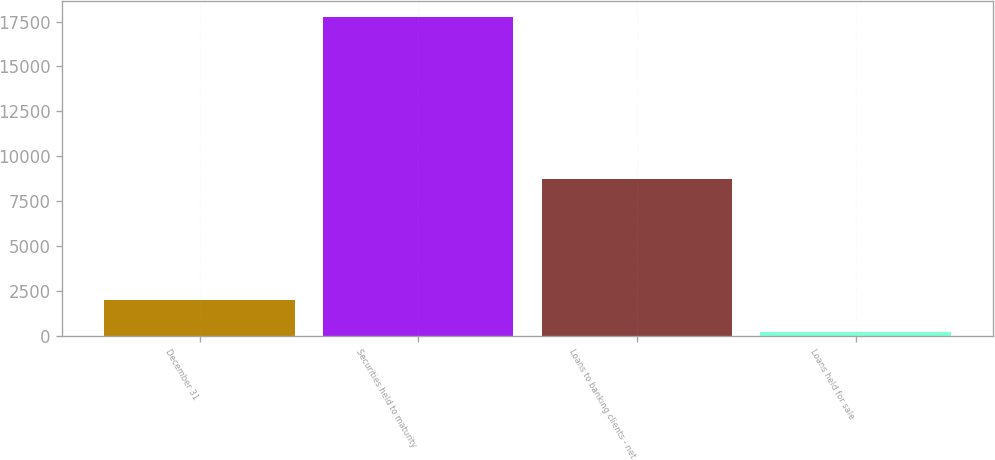Convert chart. <chart><loc_0><loc_0><loc_500><loc_500><bar_chart><fcel>December 31<fcel>Securities held to maturity<fcel>Loans to banking clients - net<fcel>Loans held for sale<nl><fcel>2010<fcel>17762<fcel>8725<fcel>185<nl></chart> 